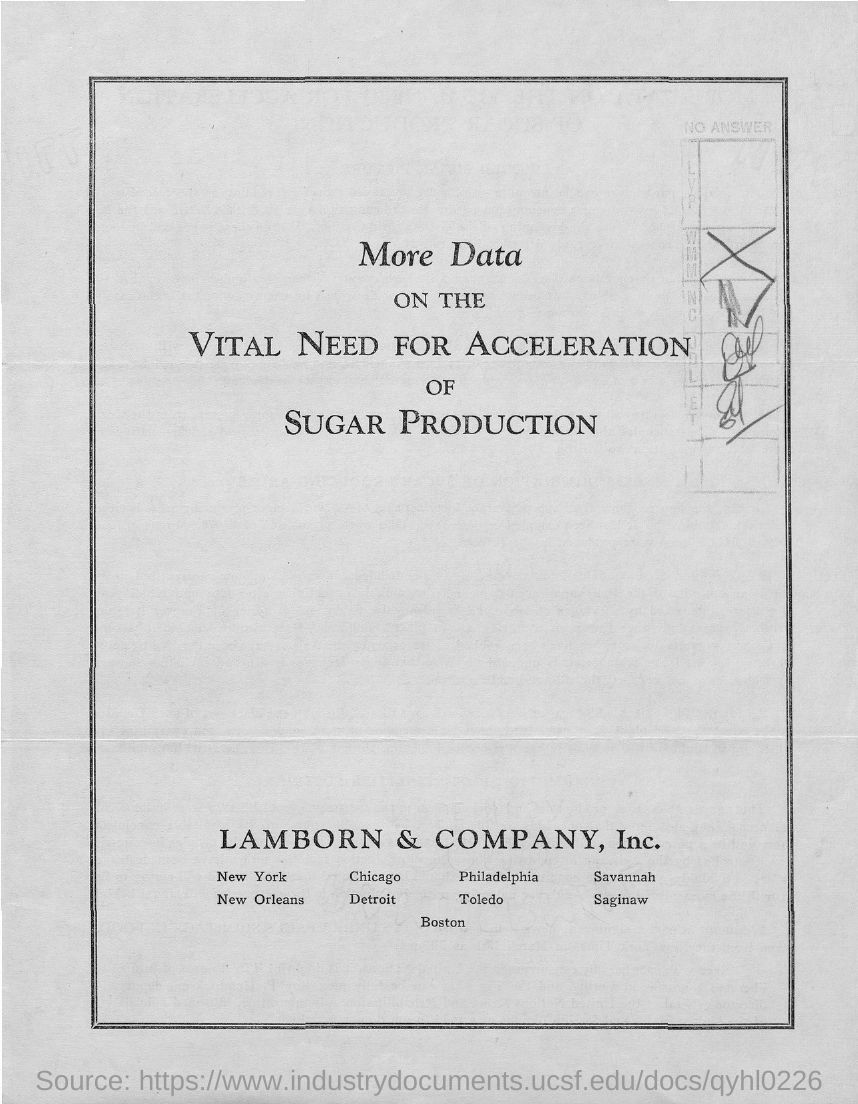What is the title of the document?
Keep it short and to the point. More data on the vital need for acceleration of sugar production. 